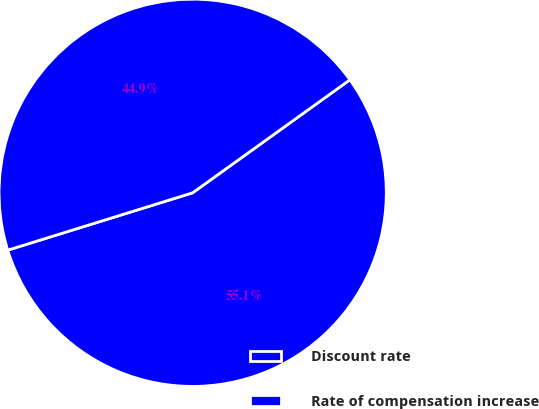Convert chart. <chart><loc_0><loc_0><loc_500><loc_500><pie_chart><fcel>Discount rate<fcel>Rate of compensation increase<nl><fcel>55.13%<fcel>44.87%<nl></chart> 